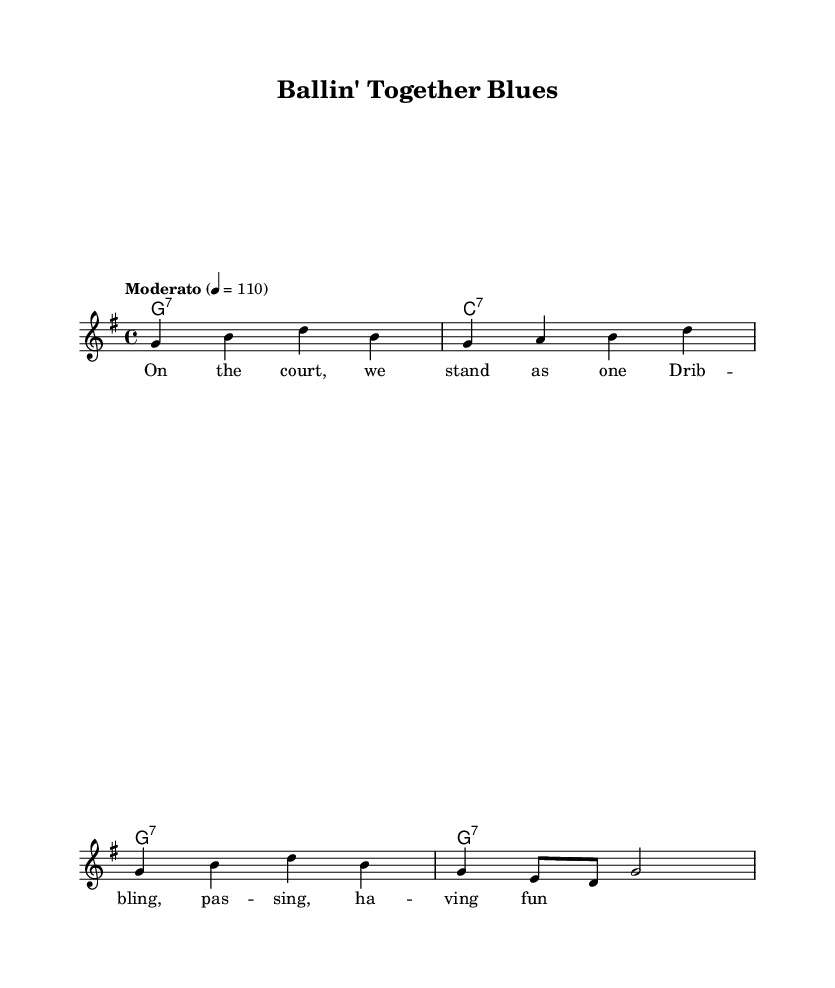what is the key signature of this music? The key signature is G major, which contains one sharp (F#). This can be determined by looking at the key signature symbol at the beginning of the staff.
Answer: G major what is the time signature of this music? The time signature is 4/4, as indicated at the beginning of the score. This means there are four beats in a measure and the quarter note receives one beat.
Answer: 4/4 what is the tempo marking for this piece? The tempo marking is "Moderato", which generally indicates a moderate pace. This is found in the tempo indication at the beginning of the score, where it's specified alongside a metronome marking of 110 beats per minute.
Answer: Moderato how many measures are there in the melody? There are four measures in the melody, visible by counting the groups of notes divided by the vertical lines (bar lines) in the score. Each group of notes between the bar lines represents one measure.
Answer: 4 what chord is played in the first measure? The chord in the first measure is G7, as specified in the harmonies section above the melody. The "g1:7" indicates a G dominant seventh chord, played for the duration of that measure.
Answer: G7 how does the structure of this piece support a blues style? The structure features repetitive chord progressions and lyrics that emphasize themes of unity and fun on the basketball court, which are characteristic of blues music. Blues often reflects personal experiences and feelings, and this piece embodies the teamwork aspect of basketball through its lyrical and harmonic structure.
Answer: Repetitive progressions what theme is highlighted in the lyrics? The lyrics highlight the theme of teamwork, emphasizing camaraderie and enjoyment while playing basketball. This is expressed through the lines that capture the essence of playing together on the court.
Answer: Teamwork 